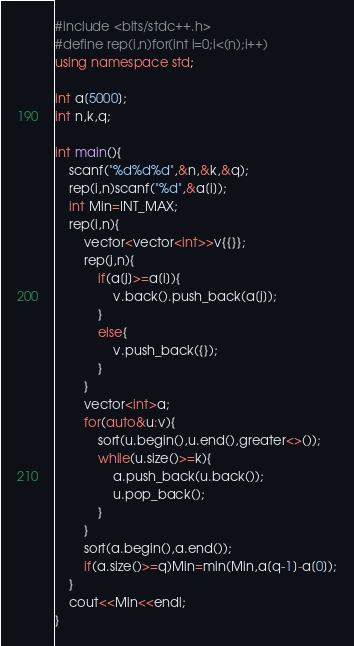<code> <loc_0><loc_0><loc_500><loc_500><_C++_>#include <bits/stdc++.h>
#define rep(i,n)for(int i=0;i<(n);i++)
using namespace std;

int a[5000];
int n,k,q;

int main(){
	scanf("%d%d%d",&n,&k,&q);
	rep(i,n)scanf("%d",&a[i]);
	int Min=INT_MAX;
	rep(i,n){
		vector<vector<int>>v{{}};
		rep(j,n){
			if(a[j]>=a[i]){
				v.back().push_back(a[j]);
			}
			else{
				v.push_back({});
			}
		}
		vector<int>a;
		for(auto&u:v){
			sort(u.begin(),u.end(),greater<>());
			while(u.size()>=k){
				a.push_back(u.back());
				u.pop_back();
			}
		}
		sort(a.begin(),a.end());
		if(a.size()>=q)Min=min(Min,a[q-1]-a[0]);
	}
	cout<<Min<<endl;
}</code> 